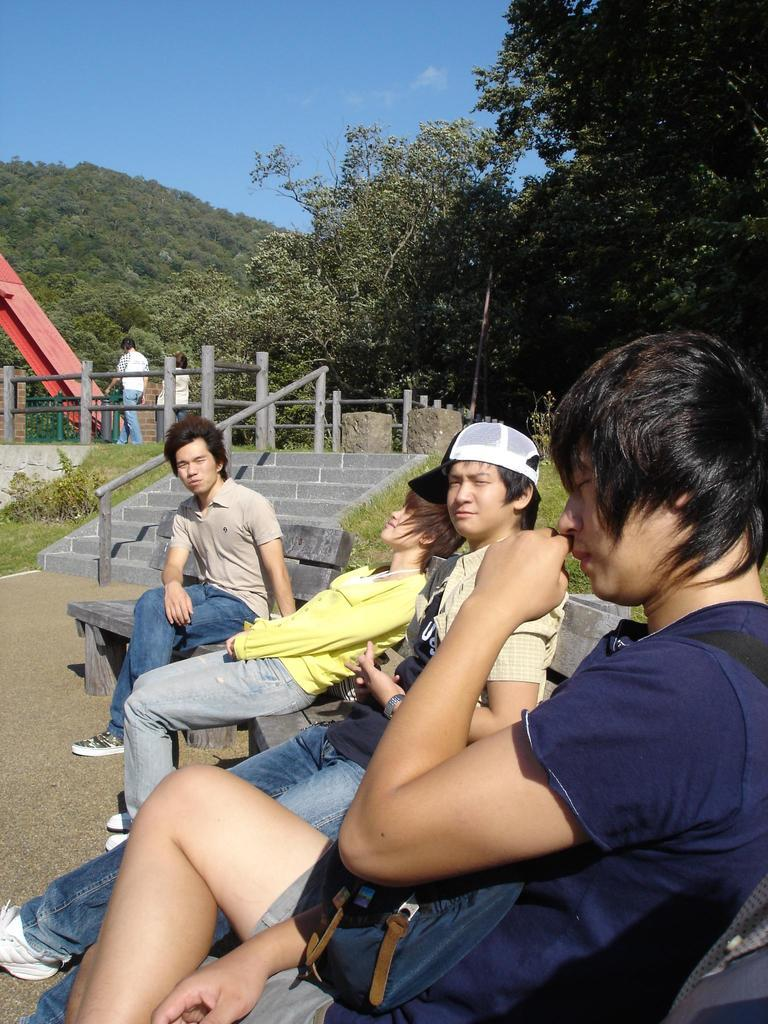What are the people in the image doing? The people in the image are sitting on benches. What can be seen in the background of the image? In the background of the image, there are steps, a railing, trees, people walking on a pavement, a mountain, and the sky. Can you describe the setting of the image? The image appears to be set outdoors, with a mountain and trees visible in the background. How many people are visible in the image? There are multiple people sitting on benches and walking on the pavement in the background. What is the boy teaching the donkey in the image? There is no boy or donkey present in the image. 